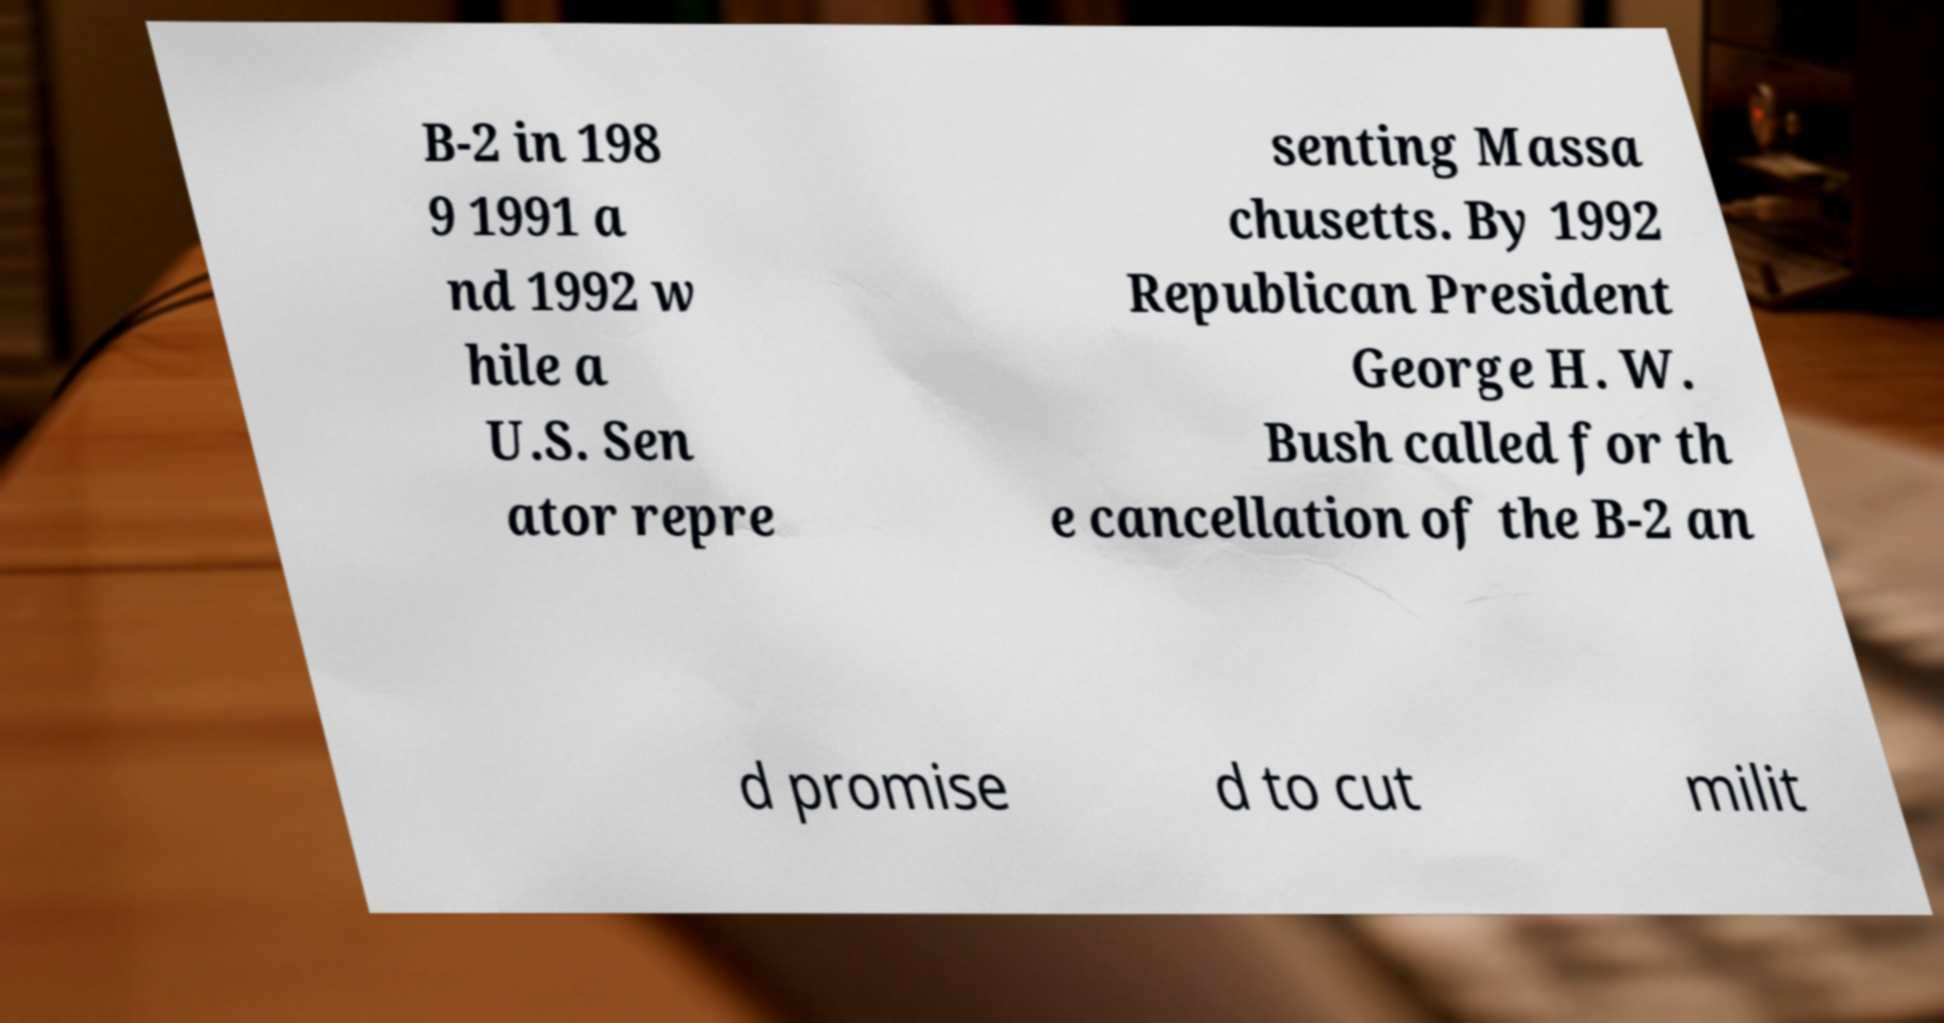What messages or text are displayed in this image? I need them in a readable, typed format. B-2 in 198 9 1991 a nd 1992 w hile a U.S. Sen ator repre senting Massa chusetts. By 1992 Republican President George H. W. Bush called for th e cancellation of the B-2 an d promise d to cut milit 